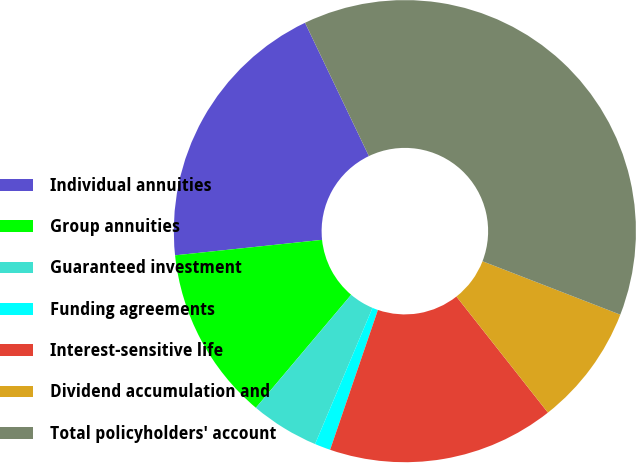<chart> <loc_0><loc_0><loc_500><loc_500><pie_chart><fcel>Individual annuities<fcel>Group annuities<fcel>Guaranteed investment<fcel>Funding agreements<fcel>Interest-sensitive life<fcel>Dividend accumulation and<fcel>Total policyholders' account<nl><fcel>19.56%<fcel>12.18%<fcel>4.8%<fcel>1.11%<fcel>15.87%<fcel>8.49%<fcel>38.0%<nl></chart> 